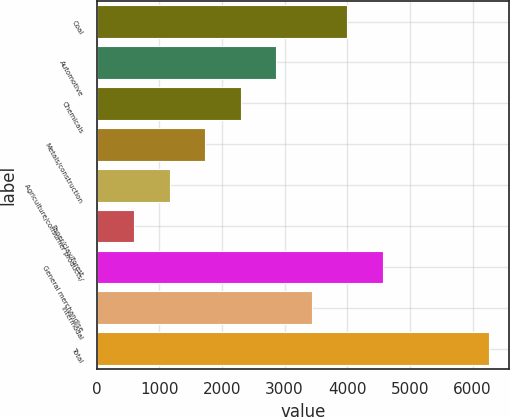<chart> <loc_0><loc_0><loc_500><loc_500><bar_chart><fcel>Coal<fcel>Automotive<fcel>Chemicals<fcel>Metals/construction<fcel>Agriculture/consumer products/<fcel>Paper/clay/forest<fcel>General merchandise<fcel>Intermodal<fcel>Total<nl><fcel>4003.2<fcel>2869.8<fcel>2303.1<fcel>1736.4<fcel>1169.7<fcel>603<fcel>4569.9<fcel>3436.5<fcel>6270<nl></chart> 